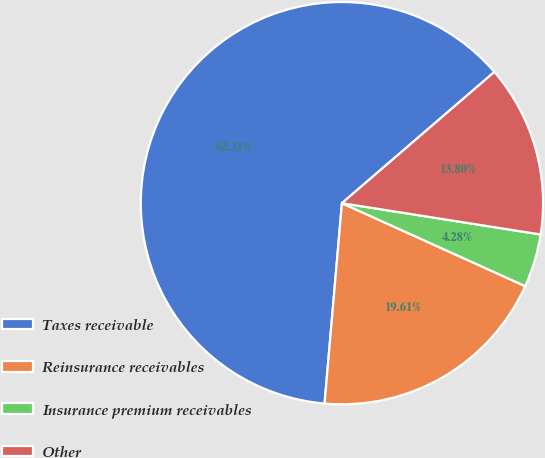Convert chart. <chart><loc_0><loc_0><loc_500><loc_500><pie_chart><fcel>Taxes receivable<fcel>Reinsurance receivables<fcel>Insurance premium receivables<fcel>Other<nl><fcel>62.31%<fcel>19.61%<fcel>4.28%<fcel>13.8%<nl></chart> 